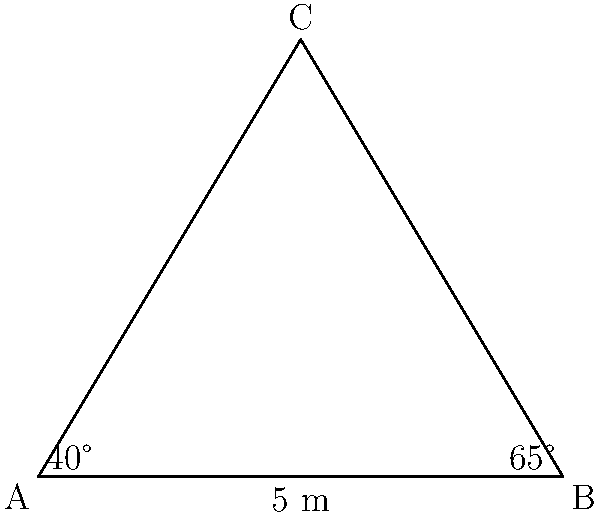At a crime scene, investigators need to calculate the area of a triangular section. The base of the triangle is 5 meters, and the angles at the base are 40° and 65°. Using the law of sines, calculate the area of this triangular section to the nearest square meter. Let's approach this step-by-step:

1) First, we need to find the third angle of the triangle:
   $180° - (40° + 65°) = 75°$

2) We can use the law of sines to find the other two sides:
   $\frac{a}{\sin A} = \frac{b}{\sin B} = \frac{c}{\sin C}$

3) Let's call the 5m side 'c'. We know:
   $\frac{c}{\sin 75°} = \frac{a}{\sin 40°} = \frac{b}{\sin 65°}$

4) We can find side 'a':
   $a = \frac{5 \cdot \sin 40°}{\sin 75°} \approx 3.42$ m

5) And side 'b':
   $b = \frac{5 \cdot \sin 65°}{\sin 75°} \approx 4.84$ m

6) Now we can use Heron's formula to calculate the area:
   $s = \frac{a+b+c}{2} = \frac{3.42 + 4.84 + 5}{2} = 6.63$

   $Area = \sqrt{s(s-a)(s-b)(s-c)}$
   $= \sqrt{6.63(6.63-3.42)(6.63-4.84)(6.63-5)}$
   $\approx 8.28$ square meters

7) Rounding to the nearest square meter, we get 8 square meters.
Answer: 8 square meters 